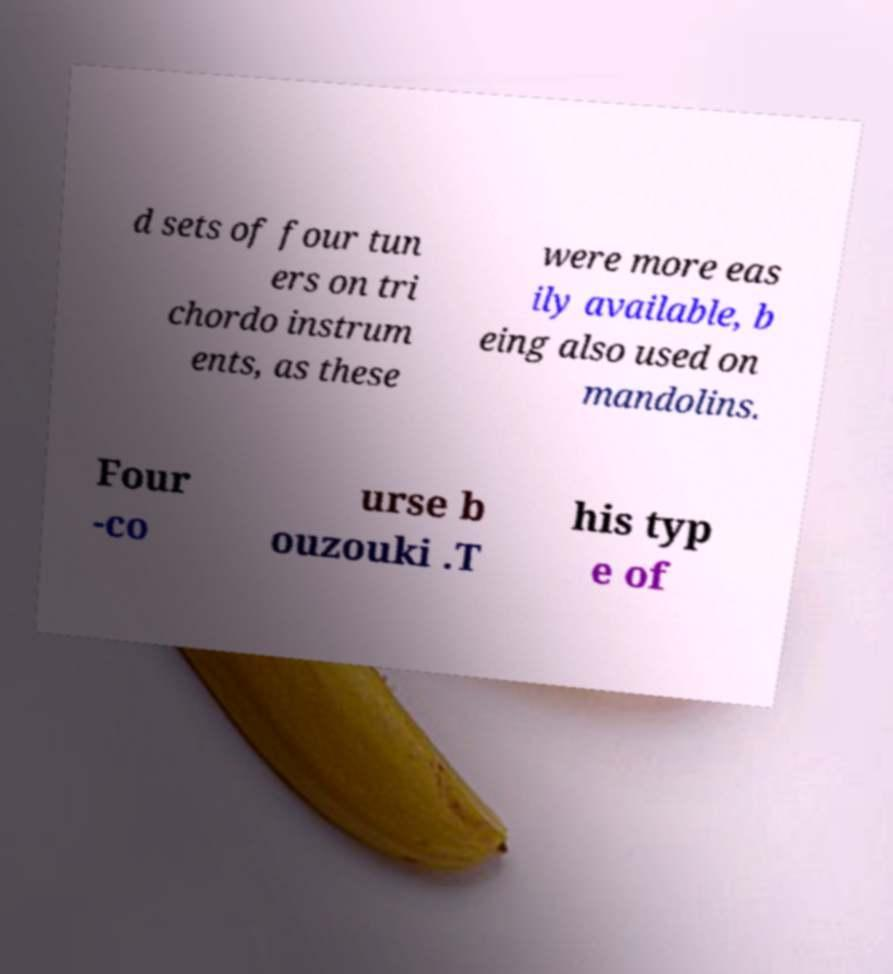Can you read and provide the text displayed in the image?This photo seems to have some interesting text. Can you extract and type it out for me? d sets of four tun ers on tri chordo instrum ents, as these were more eas ily available, b eing also used on mandolins. Four -co urse b ouzouki .T his typ e of 